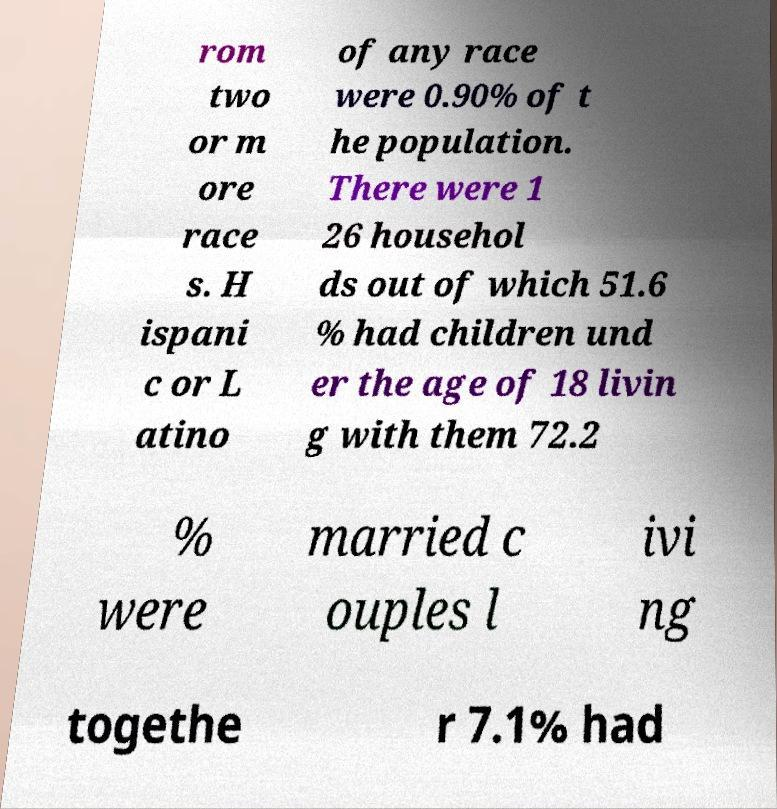Can you read and provide the text displayed in the image?This photo seems to have some interesting text. Can you extract and type it out for me? rom two or m ore race s. H ispani c or L atino of any race were 0.90% of t he population. There were 1 26 househol ds out of which 51.6 % had children und er the age of 18 livin g with them 72.2 % were married c ouples l ivi ng togethe r 7.1% had 